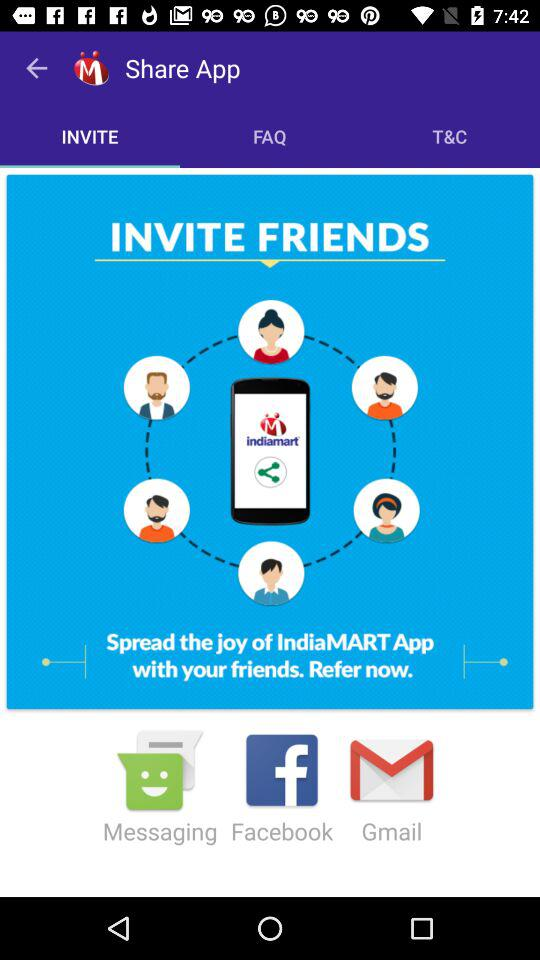What is the name of the application? The name of the application is "Share App". 